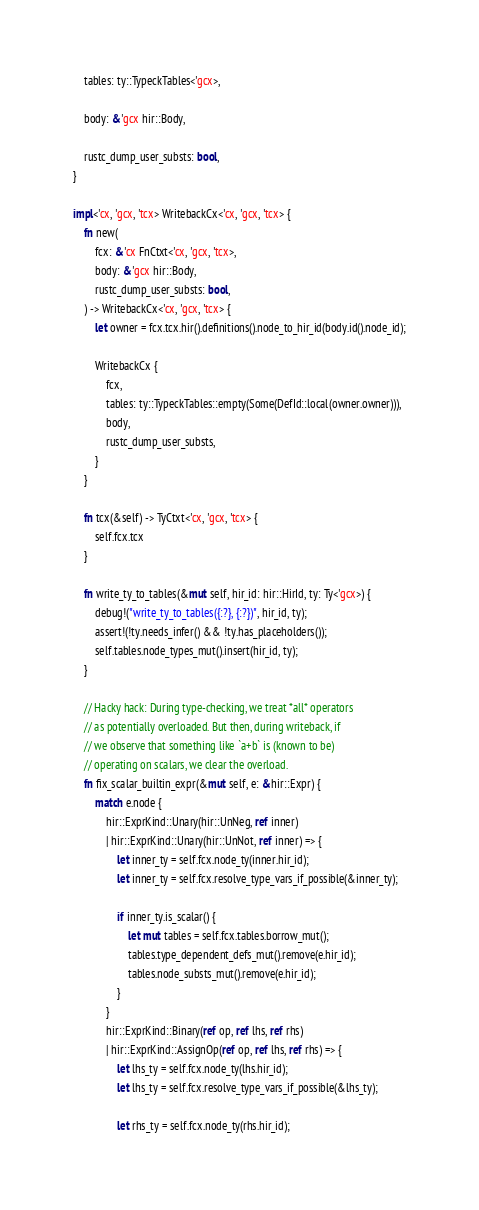Convert code to text. <code><loc_0><loc_0><loc_500><loc_500><_Rust_>    tables: ty::TypeckTables<'gcx>,

    body: &'gcx hir::Body,

    rustc_dump_user_substs: bool,
}

impl<'cx, 'gcx, 'tcx> WritebackCx<'cx, 'gcx, 'tcx> {
    fn new(
        fcx: &'cx FnCtxt<'cx, 'gcx, 'tcx>,
        body: &'gcx hir::Body,
        rustc_dump_user_substs: bool,
    ) -> WritebackCx<'cx, 'gcx, 'tcx> {
        let owner = fcx.tcx.hir().definitions().node_to_hir_id(body.id().node_id);

        WritebackCx {
            fcx,
            tables: ty::TypeckTables::empty(Some(DefId::local(owner.owner))),
            body,
            rustc_dump_user_substs,
        }
    }

    fn tcx(&self) -> TyCtxt<'cx, 'gcx, 'tcx> {
        self.fcx.tcx
    }

    fn write_ty_to_tables(&mut self, hir_id: hir::HirId, ty: Ty<'gcx>) {
        debug!("write_ty_to_tables({:?}, {:?})", hir_id, ty);
        assert!(!ty.needs_infer() && !ty.has_placeholders());
        self.tables.node_types_mut().insert(hir_id, ty);
    }

    // Hacky hack: During type-checking, we treat *all* operators
    // as potentially overloaded. But then, during writeback, if
    // we observe that something like `a+b` is (known to be)
    // operating on scalars, we clear the overload.
    fn fix_scalar_builtin_expr(&mut self, e: &hir::Expr) {
        match e.node {
            hir::ExprKind::Unary(hir::UnNeg, ref inner)
            | hir::ExprKind::Unary(hir::UnNot, ref inner) => {
                let inner_ty = self.fcx.node_ty(inner.hir_id);
                let inner_ty = self.fcx.resolve_type_vars_if_possible(&inner_ty);

                if inner_ty.is_scalar() {
                    let mut tables = self.fcx.tables.borrow_mut();
                    tables.type_dependent_defs_mut().remove(e.hir_id);
                    tables.node_substs_mut().remove(e.hir_id);
                }
            }
            hir::ExprKind::Binary(ref op, ref lhs, ref rhs)
            | hir::ExprKind::AssignOp(ref op, ref lhs, ref rhs) => {
                let lhs_ty = self.fcx.node_ty(lhs.hir_id);
                let lhs_ty = self.fcx.resolve_type_vars_if_possible(&lhs_ty);

                let rhs_ty = self.fcx.node_ty(rhs.hir_id);</code> 